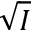<formula> <loc_0><loc_0><loc_500><loc_500>\sqrt { I }</formula> 